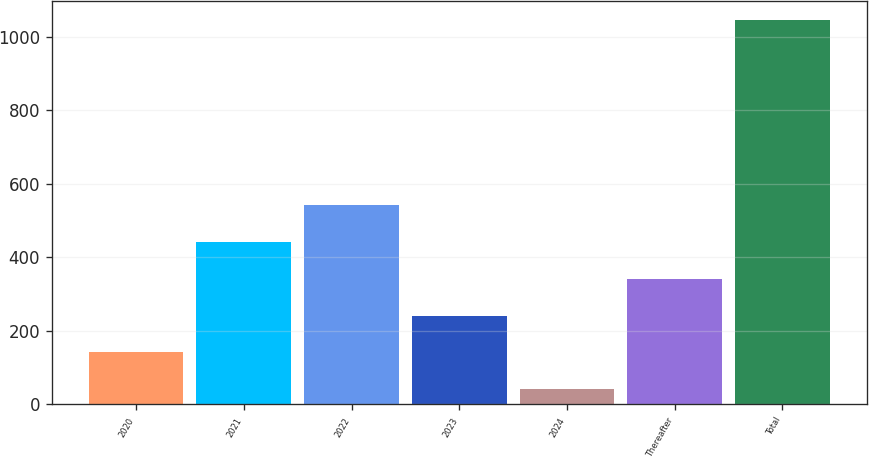Convert chart. <chart><loc_0><loc_0><loc_500><loc_500><bar_chart><fcel>2020<fcel>2021<fcel>2022<fcel>2023<fcel>2024<fcel>Thereafter<fcel>Total<nl><fcel>140.7<fcel>442.8<fcel>543.5<fcel>241.4<fcel>40<fcel>342.1<fcel>1047<nl></chart> 